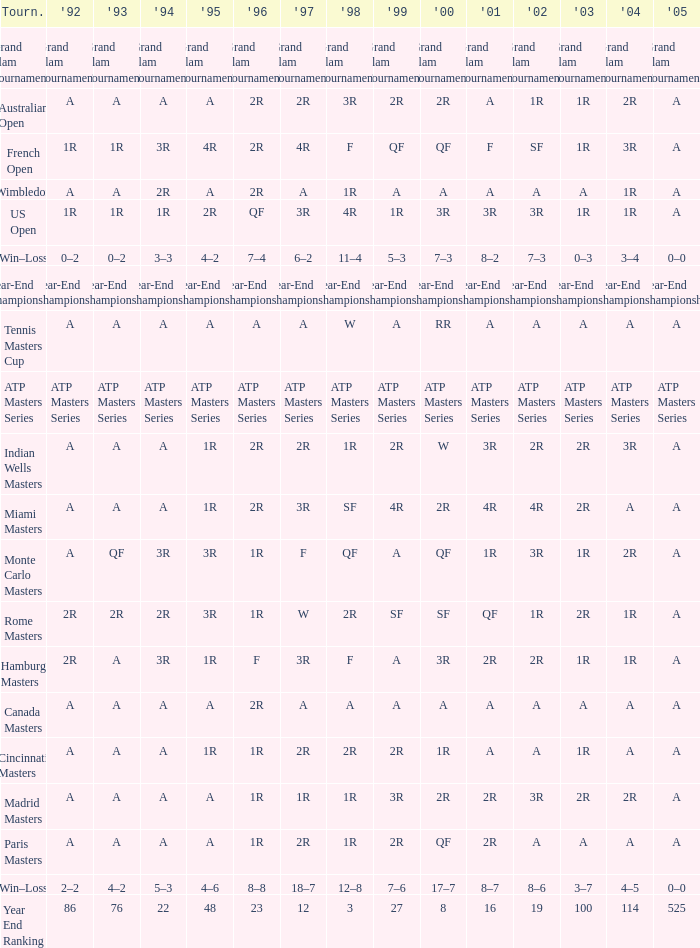What is Tournament, when 2000 is "A"? Wimbledon, Canada Masters. 